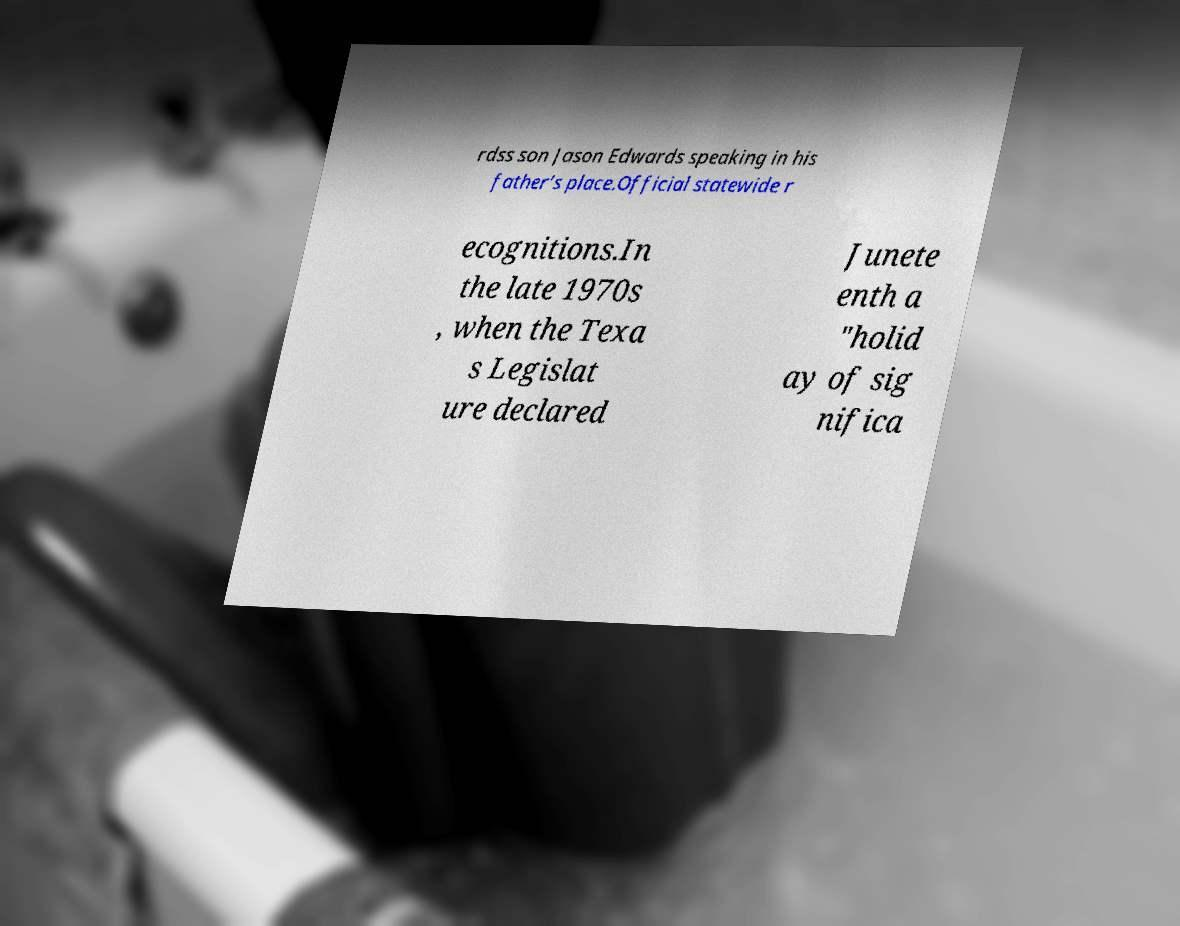There's text embedded in this image that I need extracted. Can you transcribe it verbatim? rdss son Jason Edwards speaking in his father’s place.Official statewide r ecognitions.In the late 1970s , when the Texa s Legislat ure declared Junete enth a "holid ay of sig nifica 